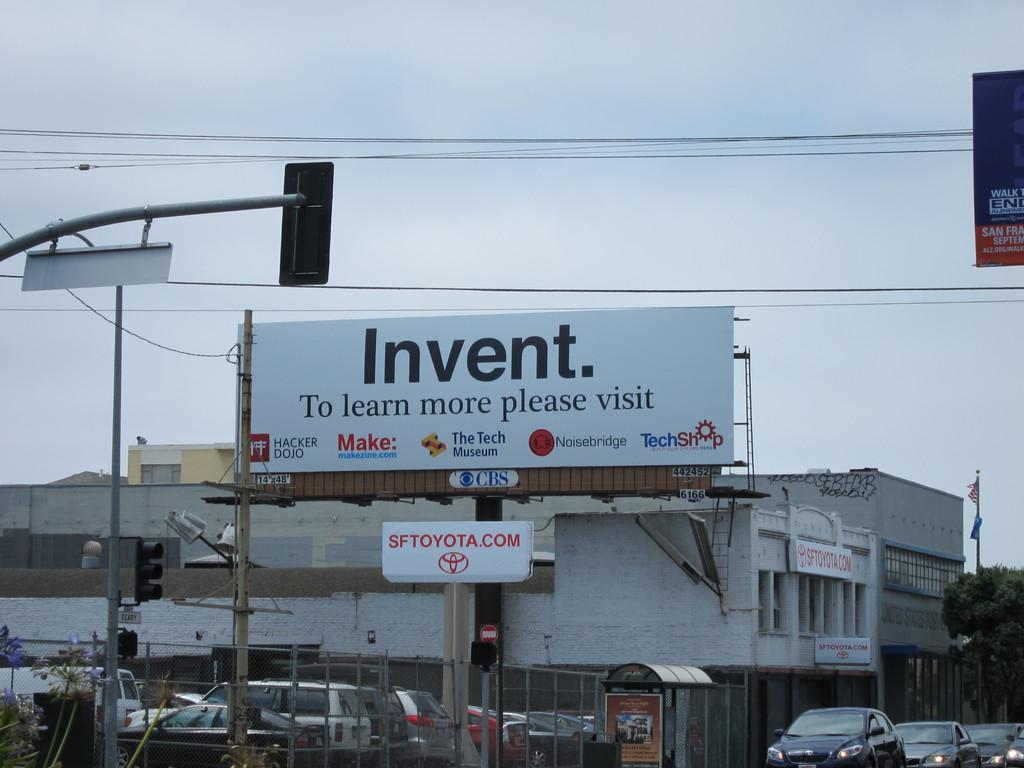<image>
Create a compact narrative representing the image presented. A billboard with the word Invent written on it sits above a Toyota sign. 